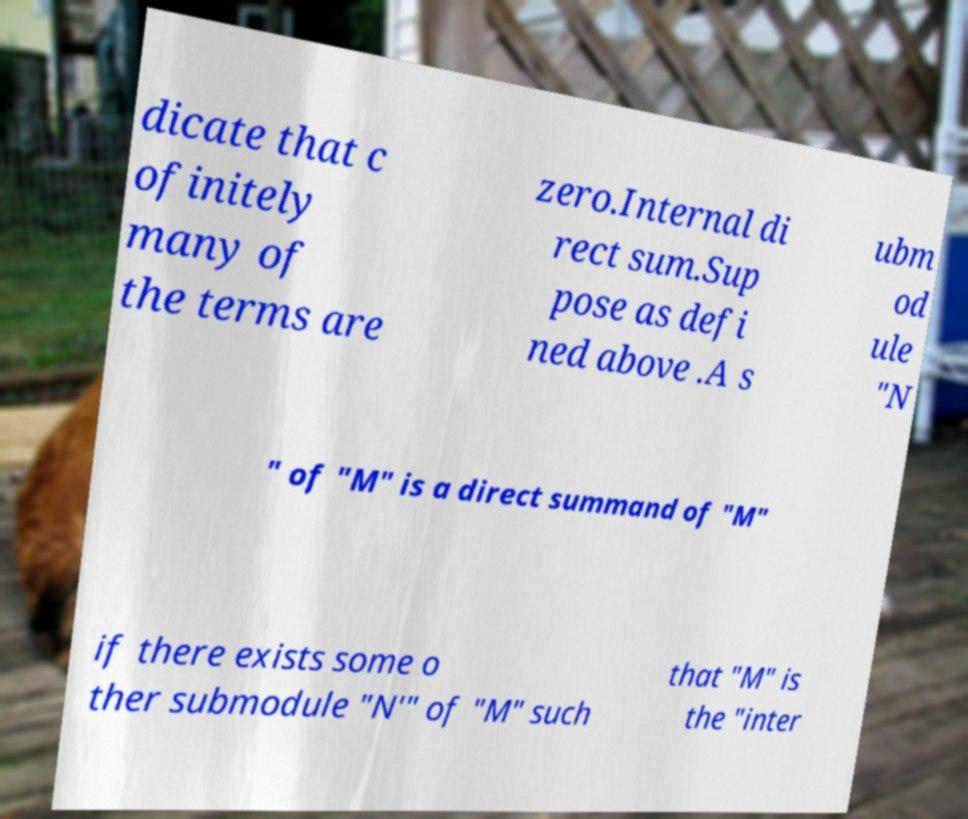Please read and relay the text visible in this image. What does it say? dicate that c ofinitely many of the terms are zero.Internal di rect sum.Sup pose as defi ned above .A s ubm od ule "N " of "M" is a direct summand of "M" if there exists some o ther submodule "N′" of "M" such that "M" is the "inter 